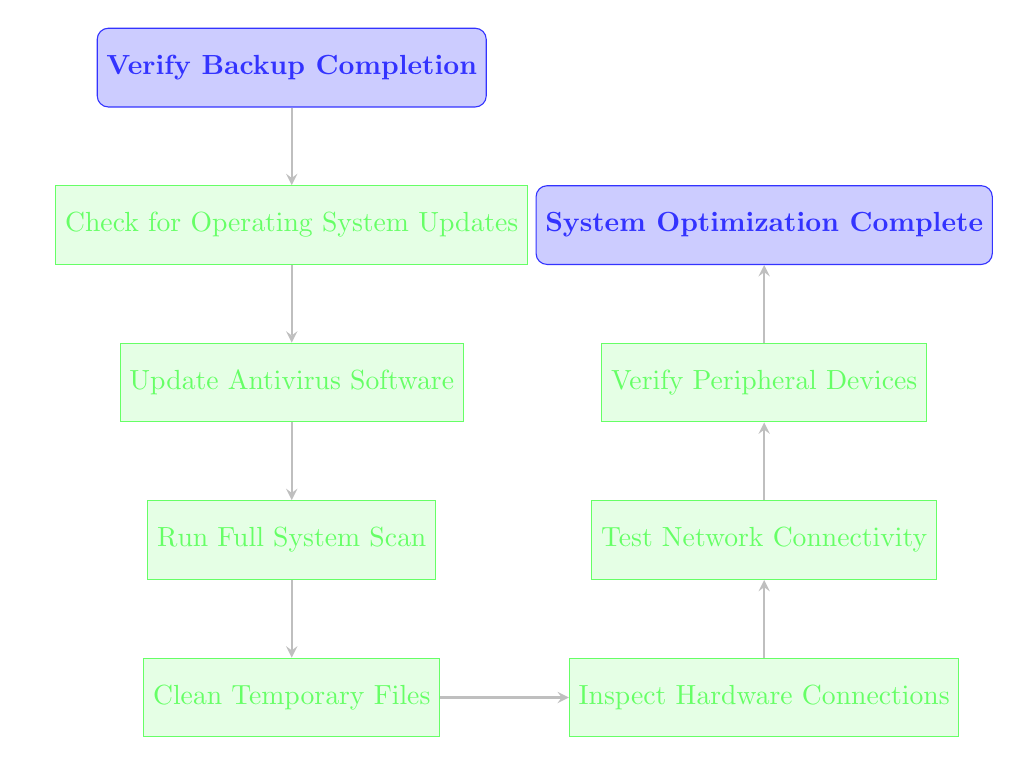What is the starting point of the flow chart? The flow chart begins with "Verify Backup Completion" as indicated at the top of the diagram, which serves as the entry point for the maintenance steps.
Answer: Verify Backup Completion What is the last step in the flow chart? The final step is "System Optimization Complete," located at the end of the flow chart, which signifies the completion of the maintenance process.
Answer: System Optimization Complete How many steps are between the start and the end? There are six steps listed between the start node and the end node in the flow chart: Check for Operating System Updates, Update Antivirus Software, Run Full System Scan, Clean Temporary Files, Inspect Hardware Connections, Test Network Connectivity, and Verify Peripheral Devices.
Answer: Six What is the next step after "Clean Temporary Files"? According to the diagram, the next step after "Clean Temporary Files" is "Inspect Hardware Connections." This can be traced directly from the flow of arrows connecting the nodes.
Answer: Inspect Hardware Connections What step comes immediately before "Test Network Connectivity"? The step immediately preceding "Test Network Connectivity" is "Inspect Hardware Connections," which is connected by an arrow in the flow, showing the progression of tasks.
Answer: Inspect Hardware Connections Which two steps are connected directly? "Update Antivirus Software" and "Run Full System Scan" are directly connected, as indicated by the arrow linking them in the sequence of maintenance tasks outlined in the diagram.
Answer: Update Antivirus Software, Run Full System Scan What process follows the completion of the system scan? After finishing the "Run Full System Scan," the flow chart indicates that the next process is "Clean Temporary Files," as shown by the arrow leading to this node.
Answer: Clean Temporary Files How many processes must be completed before verifying peripheral devices? Before reaching the "Verify Peripheral Devices" step, five processes need to be completed: Check for Operating System Updates, Update Antivirus Software, Run Full System Scan, Clean Temporary Files, and Inspect Hardware Connections. This sequential approach marks the completion of each prerequisite task before verification.
Answer: Five What is the relationship between "Test Network Connectivity" and "Verify Peripheral Devices"? "Test Network Connectivity" is a prerequisite step that must be completed before moving on to "Verify Peripheral Devices," as indicated by the direct arrow connecting these two processes in the flow chart.
Answer: Prerequisite 